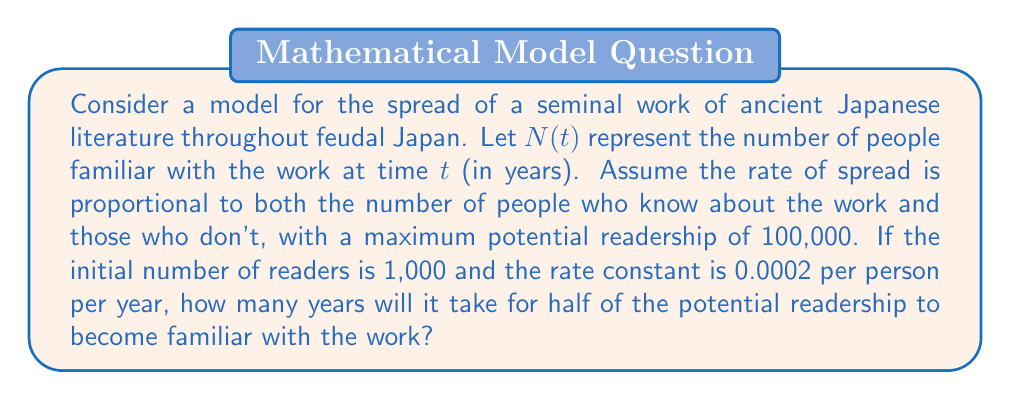Provide a solution to this math problem. 1) We can model this spread using the logistic differential equation:

   $$\frac{dN}{dt} = kN(M-N)$$

   where $k$ is the rate constant, and $M$ is the maximum potential readership.

2) Given:
   $k = 0.0002$, $M = 100,000$, $N(0) = 1,000$

3) The solution to this differential equation is:

   $$N(t) = \frac{M}{1 + (\frac{M}{N_0} - 1)e^{-kMt}}$$

4) We want to find $t$ when $N(t) = 50,000$ (half of the maximum readership).

5) Substituting the values:

   $$50,000 = \frac{100,000}{1 + (\frac{100,000}{1,000} - 1)e^{-0.0002 \cdot 100,000 \cdot t}}$$

6) Simplifying:

   $$\frac{1}{2} = \frac{1}{1 + 99e^{-20t}}$$

7) Solving for $t$:

   $$1 + 99e^{-20t} = 2$$
   $$99e^{-20t} = 1$$
   $$e^{-20t} = \frac{1}{99}$$
   $$-20t = \ln(\frac{1}{99})$$
   $$t = -\frac{1}{20}\ln(\frac{1}{99}) = \frac{1}{20}\ln(99)$$

8) Calculating the final value:

   $$t \approx 0.23015 \text{ years}$$

9) Converting to days:

   $$0.23015 \text{ years} \cdot 365 \text{ days/year} \approx 84 \text{ days}$$
Answer: 84 days 